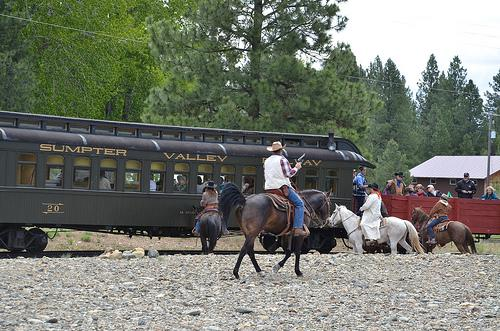Question: what color is the closest horse?
Choices:
A. White.
B. Brown.
C. Black.
D. Beige.
Answer with the letter. Answer: B Question: what are the men on horses doing?
Choices:
A. Herding cows.
B. Helping the train passengers.
C. Rodeo roping.
D. Robbing train.
Answer with the letter. Answer: D Question: how many train cars are in the photo?
Choices:
A. 3.
B. 4.
C. 2.
D. 5.
Answer with the letter. Answer: C Question: what word is farthest left in the picture?
Choices:
A. Silly.
B. Summer.
C. Sumpter.
D. Supple.
Answer with the letter. Answer: C 